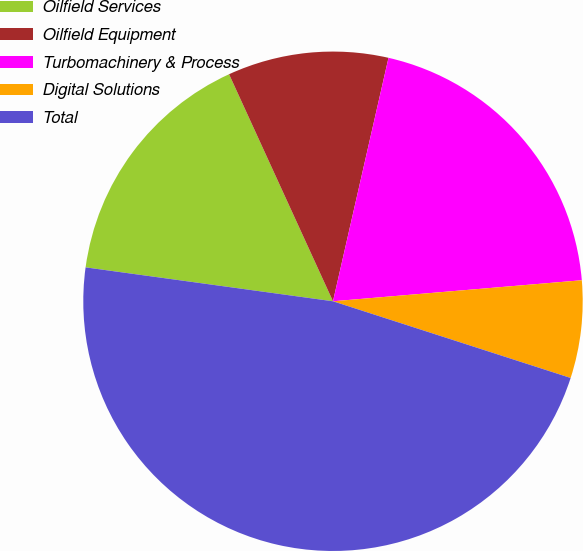Convert chart. <chart><loc_0><loc_0><loc_500><loc_500><pie_chart><fcel>Oilfield Services<fcel>Oilfield Equipment<fcel>Turbomachinery & Process<fcel>Digital Solutions<fcel>Total<nl><fcel>16.0%<fcel>10.4%<fcel>20.09%<fcel>6.31%<fcel>47.2%<nl></chart> 